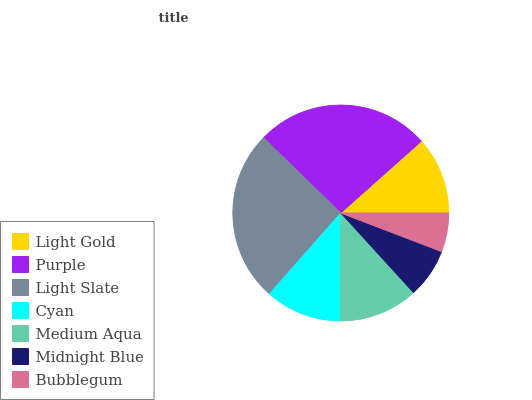Is Bubblegum the minimum?
Answer yes or no. Yes. Is Purple the maximum?
Answer yes or no. Yes. Is Light Slate the minimum?
Answer yes or no. No. Is Light Slate the maximum?
Answer yes or no. No. Is Purple greater than Light Slate?
Answer yes or no. Yes. Is Light Slate less than Purple?
Answer yes or no. Yes. Is Light Slate greater than Purple?
Answer yes or no. No. Is Purple less than Light Slate?
Answer yes or no. No. Is Light Gold the high median?
Answer yes or no. Yes. Is Light Gold the low median?
Answer yes or no. Yes. Is Bubblegum the high median?
Answer yes or no. No. Is Bubblegum the low median?
Answer yes or no. No. 